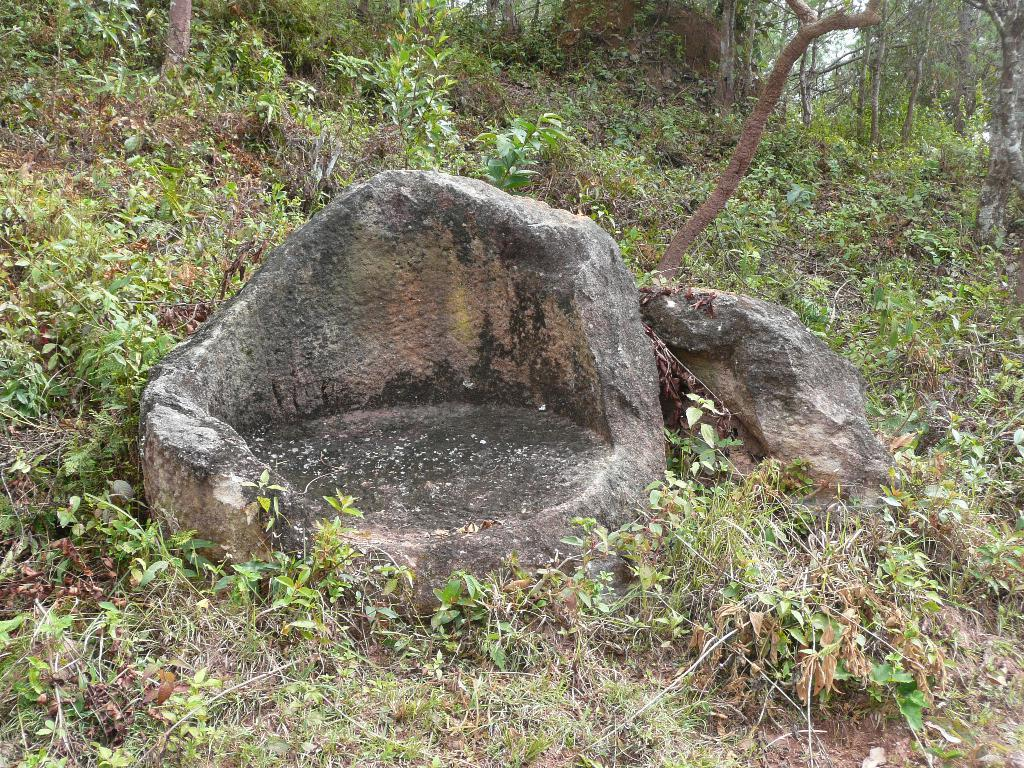What type of vegetation is visible in the image? There are trees in the image. What type of ground cover is present in the image? There is grass in the image. What type of natural feature can be seen in the image? There are rocks in the image. How many beds are visible in the image? There are no beds present in the image. What type of stocking is being worn by the trees in the image? There are no stockings present in the image, as trees do not wear clothing. 